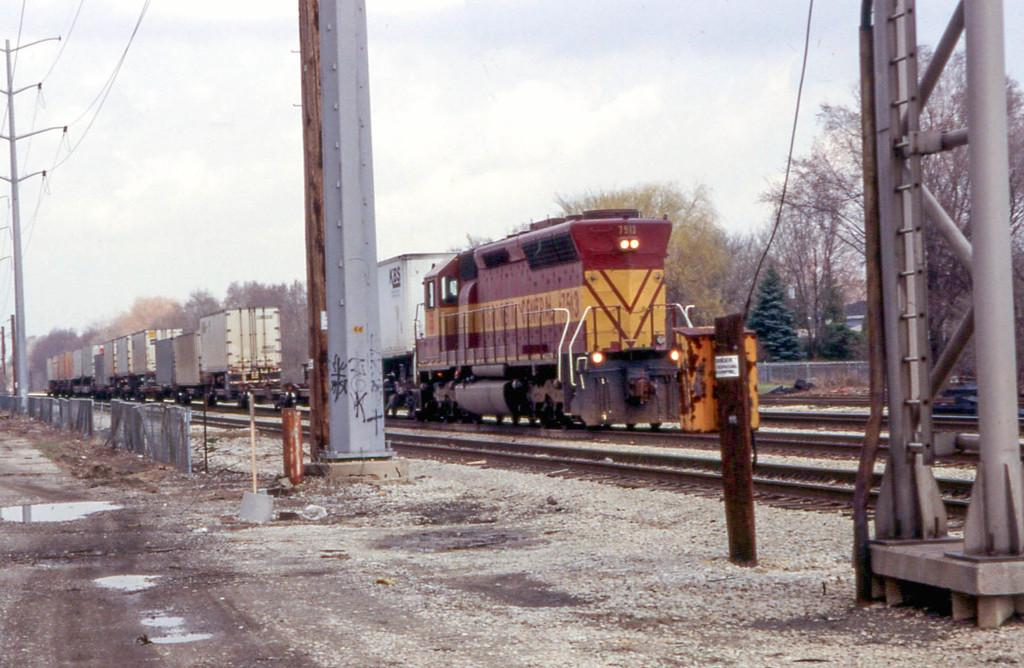What is the main subject of the image? There is a train in the image. What is the train situated on? The train is on tracks. What type of vegetation is visible near the train? There are trees beside the train. What structures can be seen in the image? There are poles and a fence in the image. What else is present in the image? Cables are present in the image, and there is water visible. What type of holiday is being celebrated by the cent in the image? There is no cent or holiday present in the image; it features a train on tracks with trees, poles, a fence, cables, and water. 